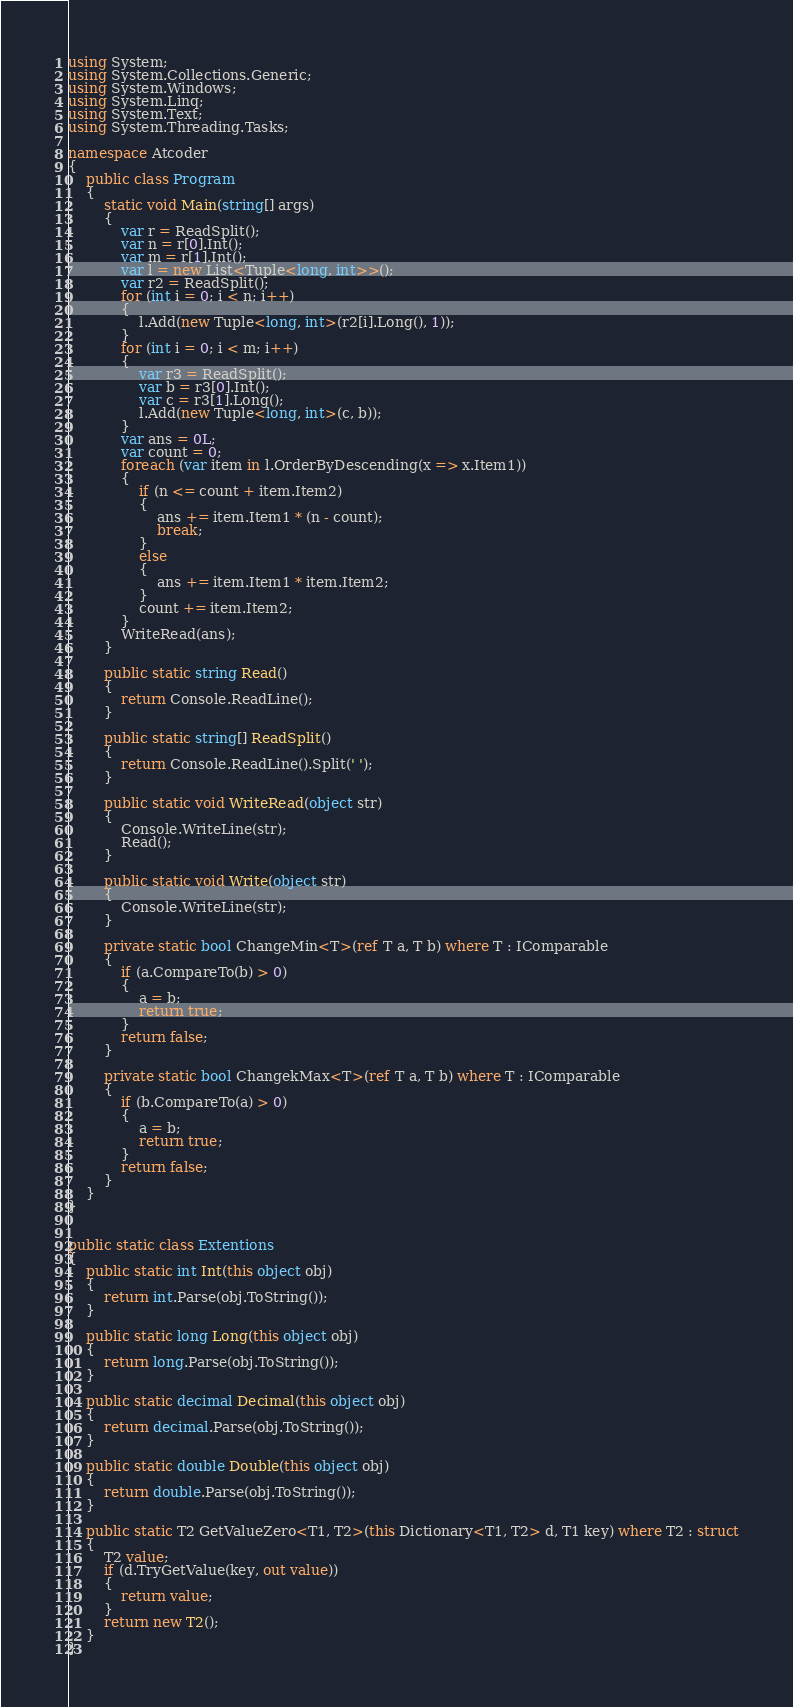<code> <loc_0><loc_0><loc_500><loc_500><_C#_>using System;
using System.Collections.Generic;
using System.Windows;
using System.Linq;
using System.Text;
using System.Threading.Tasks;

namespace Atcoder
{
    public class Program
    {
        static void Main(string[] args)
        {
            var r = ReadSplit();
            var n = r[0].Int();
            var m = r[1].Int();
            var l = new List<Tuple<long, int>>();
            var r2 = ReadSplit();
            for (int i = 0; i < n; i++)
            {
                l.Add(new Tuple<long, int>(r2[i].Long(), 1));
            }
            for (int i = 0; i < m; i++)
            {
                var r3 = ReadSplit();
                var b = r3[0].Int();
                var c = r3[1].Long();
                l.Add(new Tuple<long, int>(c, b));
            }
            var ans = 0L;
            var count = 0;
            foreach (var item in l.OrderByDescending(x => x.Item1))
            {
                if (n <= count + item.Item2)
                {
                    ans += item.Item1 * (n - count);
                    break;
                }
                else
                {
                    ans += item.Item1 * item.Item2;
                }
                count += item.Item2;
            }
            WriteRead(ans);
        }

        public static string Read()
        {
            return Console.ReadLine();
        }

        public static string[] ReadSplit()
        {
            return Console.ReadLine().Split(' ');
        }

        public static void WriteRead(object str)
        {
            Console.WriteLine(str);
            Read();
        }

        public static void Write(object str)
        {
            Console.WriteLine(str);
        }

        private static bool ChangeMin<T>(ref T a, T b) where T : IComparable
        {
            if (a.CompareTo(b) > 0)
            {
                a = b;
                return true;
            }
            return false;
        }

        private static bool ChangekMax<T>(ref T a, T b) where T : IComparable
        {
            if (b.CompareTo(a) > 0)
            {
                a = b;
                return true;
            }
            return false;
        }
    }
}


public static class Extentions
{
    public static int Int(this object obj)
    {
        return int.Parse(obj.ToString());
    }

    public static long Long(this object obj)
    {
        return long.Parse(obj.ToString());
    }

    public static decimal Decimal(this object obj)
    {
        return decimal.Parse(obj.ToString());
    }

    public static double Double(this object obj)
    {
        return double.Parse(obj.ToString());
    }

    public static T2 GetValueZero<T1, T2>(this Dictionary<T1, T2> d, T1 key) where T2 : struct
    {
        T2 value;
        if (d.TryGetValue(key, out value))
        {
            return value;
        }
        return new T2();
    }
}

</code> 